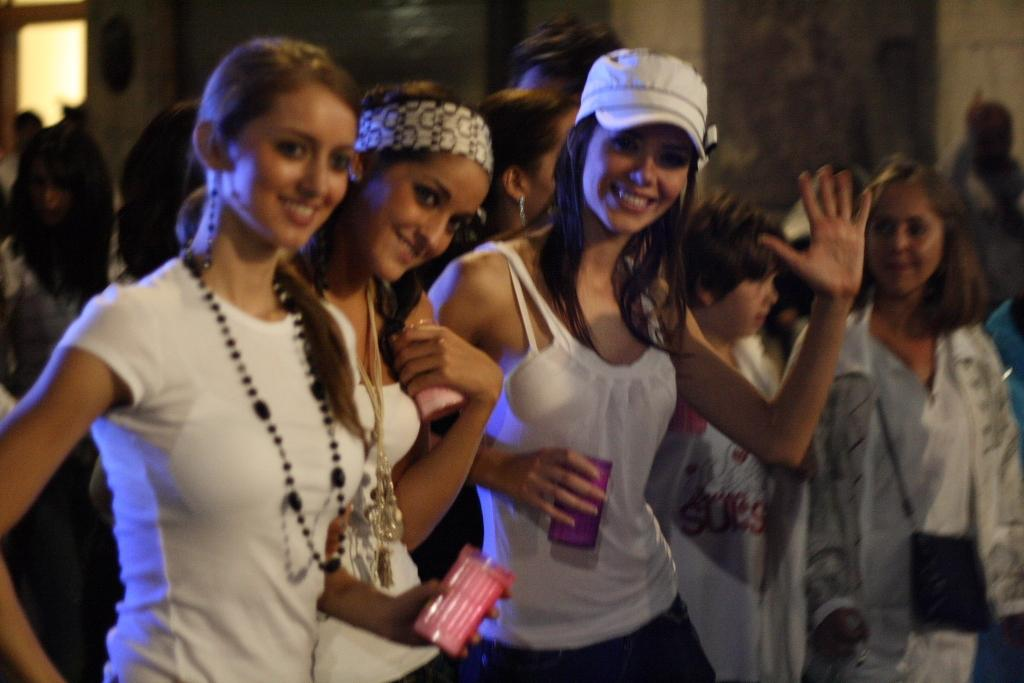How many people are in the image? There are people in the image. Can you describe their position in the image? The people are standing in the center of the image. How many women are in the group? There are three women in the group. What are the women doing in the image? The women are posing for the picture. What type of ring can be seen on the women's fingers in the image? There is no ring visible on the women's fingers in the image. Is this a birthday celebration, as indicated by the presence of a cake or candles? There is no cake or candles present in the image, so it cannot be determined if this is a birthday celebration. 